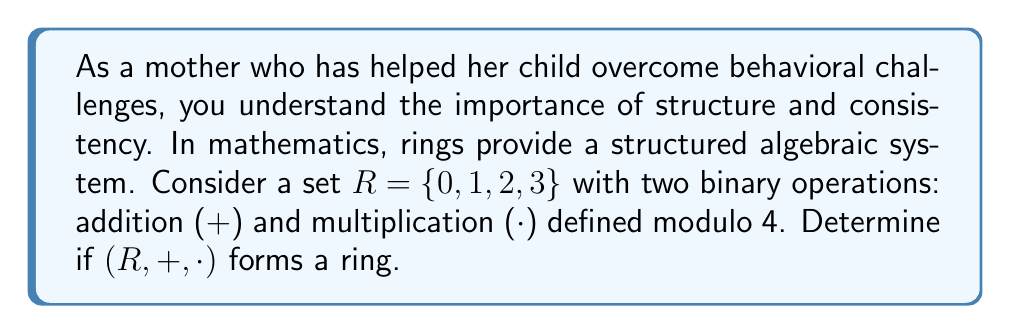Provide a solution to this math problem. To determine if $(R, +, \cdot)$ forms a ring, we need to check if it satisfies all the ring axioms:

1. $(R, +)$ is an abelian group:
   a) Closure: For all $a, b \in R$, $a + b \in R$ (mod 4)
   b) Associativity: $(a + b) + c = a + (b + c)$ for all $a, b, c \in R$
   c) Commutativity: $a + b = b + a$ for all $a, b \in R$
   d) Identity: $0$ is the additive identity
   e) Inverse: For each $a \in R$, there exists $-a \in R$ such that $a + (-a) = 0$

2. $(R, \cdot)$ is a monoid:
   a) Closure: For all $a, b \in R$, $a \cdot b \in R$ (mod 4)
   b) Associativity: $(a \cdot b) \cdot c = a \cdot (b \cdot c)$ for all $a, b, c \in R$
   c) Identity: $1$ is the multiplicative identity

3. Distributive laws:
   a) $a \cdot (b + c) = (a \cdot b) + (a \cdot c)$ for all $a, b, c \in R$
   b) $(b + c) \cdot a = (b \cdot a) + (c \cdot a)$ for all $a, b, c \in R$

Let's verify each axiom:

1. $(R, +)$ is an abelian group:
   a) Closure: Addition modulo 4 always results in an element of $R$
   b) Associativity: Addition is associative in modular arithmetic
   c) Commutativity: Addition is commutative in modular arithmetic
   d) Identity: $0$ is the additive identity
   e) Inverse: $0 + 0 = 0$, $1 + 3 = 0$, $2 + 2 = 0$, $3 + 1 = 0$ (mod 4)

2. $(R, \cdot)$ is a monoid:
   a) Closure: Multiplication modulo 4 always results in an element of $R$
   b) Associativity: Multiplication is associative in modular arithmetic
   c) Identity: $1$ is the multiplicative identity

3. Distributive laws:
   The distributive laws hold in modular arithmetic

Since all axioms are satisfied, $(R, +, \cdot)$ forms a ring.
Answer: Yes, $(R, +, \cdot)$ forms a ring. 